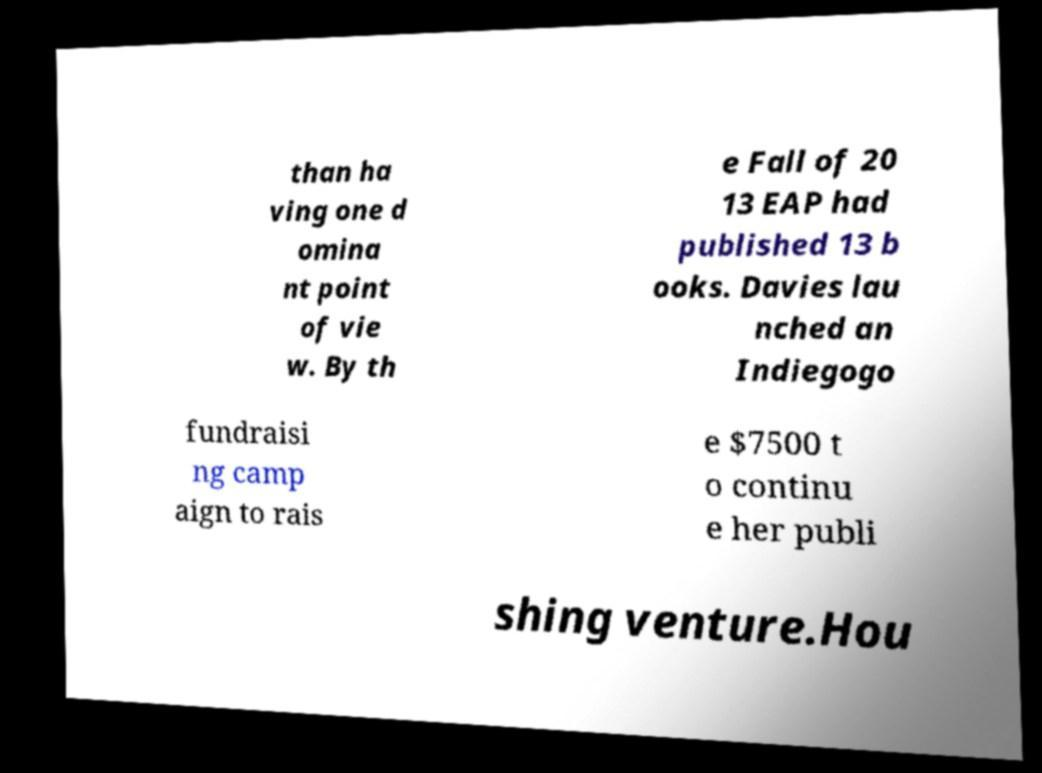What messages or text are displayed in this image? I need them in a readable, typed format. than ha ving one d omina nt point of vie w. By th e Fall of 20 13 EAP had published 13 b ooks. Davies lau nched an Indiegogo fundraisi ng camp aign to rais e $7500 t o continu e her publi shing venture.Hou 